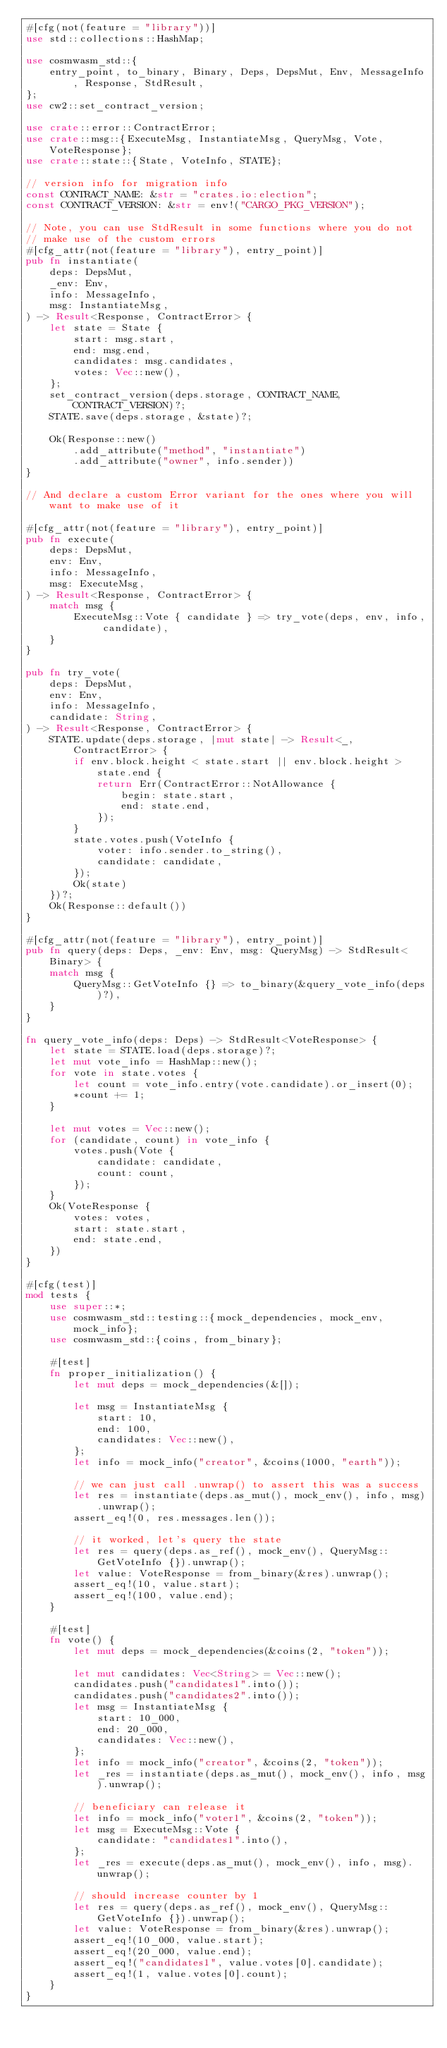<code> <loc_0><loc_0><loc_500><loc_500><_Rust_>#[cfg(not(feature = "library"))]
use std::collections::HashMap;

use cosmwasm_std::{
    entry_point, to_binary, Binary, Deps, DepsMut, Env, MessageInfo, Response, StdResult,
};
use cw2::set_contract_version;

use crate::error::ContractError;
use crate::msg::{ExecuteMsg, InstantiateMsg, QueryMsg, Vote, VoteResponse};
use crate::state::{State, VoteInfo, STATE};

// version info for migration info
const CONTRACT_NAME: &str = "crates.io:election";
const CONTRACT_VERSION: &str = env!("CARGO_PKG_VERSION");

// Note, you can use StdResult in some functions where you do not
// make use of the custom errors
#[cfg_attr(not(feature = "library"), entry_point)]
pub fn instantiate(
    deps: DepsMut,
    _env: Env,
    info: MessageInfo,
    msg: InstantiateMsg,
) -> Result<Response, ContractError> {
    let state = State {
        start: msg.start,
        end: msg.end,
        candidates: msg.candidates,
        votes: Vec::new(),
    };
    set_contract_version(deps.storage, CONTRACT_NAME, CONTRACT_VERSION)?;
    STATE.save(deps.storage, &state)?;

    Ok(Response::new()
        .add_attribute("method", "instantiate")
        .add_attribute("owner", info.sender))
}

// And declare a custom Error variant for the ones where you will want to make use of it

#[cfg_attr(not(feature = "library"), entry_point)]
pub fn execute(
    deps: DepsMut,
    env: Env,
    info: MessageInfo,
    msg: ExecuteMsg,
) -> Result<Response, ContractError> {
    match msg {
        ExecuteMsg::Vote { candidate } => try_vote(deps, env, info, candidate),
    }
}

pub fn try_vote(
    deps: DepsMut,
    env: Env,
    info: MessageInfo,
    candidate: String,
) -> Result<Response, ContractError> {
    STATE.update(deps.storage, |mut state| -> Result<_, ContractError> {
        if env.block.height < state.start || env.block.height > state.end {
            return Err(ContractError::NotAllowance {
                begin: state.start,
                end: state.end,
            });
        }
        state.votes.push(VoteInfo {
            voter: info.sender.to_string(),
            candidate: candidate,
        });
        Ok(state)
    })?;
    Ok(Response::default())
}

#[cfg_attr(not(feature = "library"), entry_point)]
pub fn query(deps: Deps, _env: Env, msg: QueryMsg) -> StdResult<Binary> {
    match msg {
        QueryMsg::GetVoteInfo {} => to_binary(&query_vote_info(deps)?),
    }
}

fn query_vote_info(deps: Deps) -> StdResult<VoteResponse> {
    let state = STATE.load(deps.storage)?;
    let mut vote_info = HashMap::new();
    for vote in state.votes {
        let count = vote_info.entry(vote.candidate).or_insert(0);
        *count += 1;
    }

    let mut votes = Vec::new();
    for (candidate, count) in vote_info {
        votes.push(Vote {
            candidate: candidate,
            count: count,
        });
    }
    Ok(VoteResponse {
        votes: votes,
        start: state.start,
        end: state.end,
    })
}

#[cfg(test)]
mod tests {
    use super::*;
    use cosmwasm_std::testing::{mock_dependencies, mock_env, mock_info};
    use cosmwasm_std::{coins, from_binary};

    #[test]
    fn proper_initialization() {
        let mut deps = mock_dependencies(&[]);

        let msg = InstantiateMsg {
            start: 10,
            end: 100,
            candidates: Vec::new(),
        };
        let info = mock_info("creator", &coins(1000, "earth"));

        // we can just call .unwrap() to assert this was a success
        let res = instantiate(deps.as_mut(), mock_env(), info, msg).unwrap();
        assert_eq!(0, res.messages.len());

        // it worked, let's query the state
        let res = query(deps.as_ref(), mock_env(), QueryMsg::GetVoteInfo {}).unwrap();
        let value: VoteResponse = from_binary(&res).unwrap();
        assert_eq!(10, value.start);
        assert_eq!(100, value.end);
    }

    #[test]
    fn vote() {
        let mut deps = mock_dependencies(&coins(2, "token"));

        let mut candidates: Vec<String> = Vec::new();
        candidates.push("candidates1".into());
        candidates.push("candidates2".into());
        let msg = InstantiateMsg {
            start: 10_000,
            end: 20_000,
            candidates: Vec::new(),
        };
        let info = mock_info("creator", &coins(2, "token"));
        let _res = instantiate(deps.as_mut(), mock_env(), info, msg).unwrap();

        // beneficiary can release it
        let info = mock_info("voter1", &coins(2, "token"));
        let msg = ExecuteMsg::Vote {
            candidate: "candidates1".into(),
        };
        let _res = execute(deps.as_mut(), mock_env(), info, msg).unwrap();

        // should increase counter by 1
        let res = query(deps.as_ref(), mock_env(), QueryMsg::GetVoteInfo {}).unwrap();
        let value: VoteResponse = from_binary(&res).unwrap();
        assert_eq!(10_000, value.start);
        assert_eq!(20_000, value.end);
        assert_eq!("candidates1", value.votes[0].candidate);
        assert_eq!(1, value.votes[0].count);
    }
}
</code> 